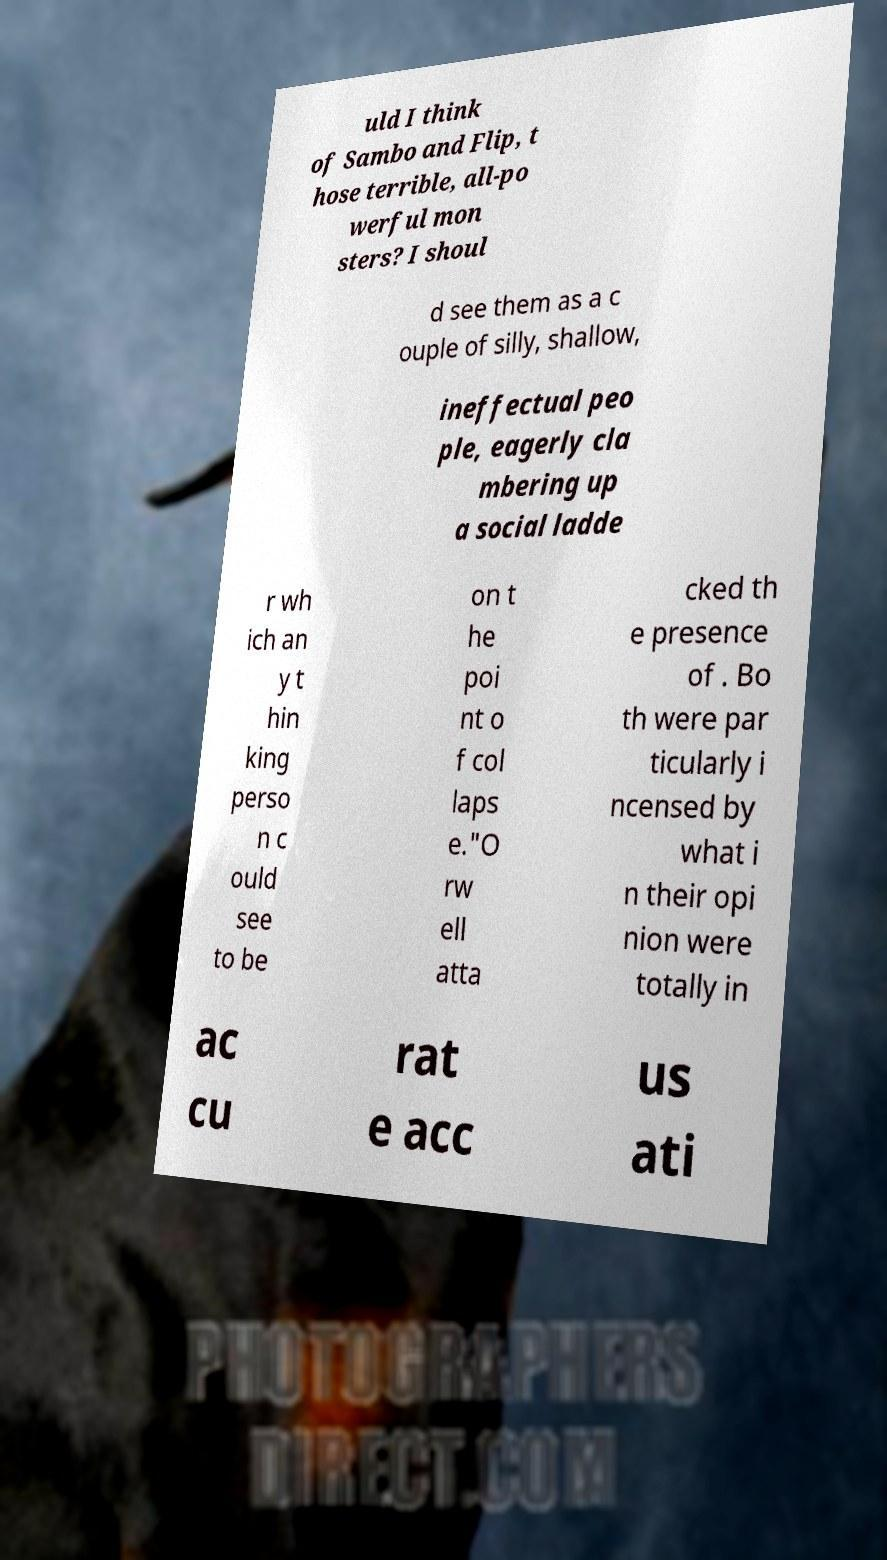Please identify and transcribe the text found in this image. uld I think of Sambo and Flip, t hose terrible, all-po werful mon sters? I shoul d see them as a c ouple of silly, shallow, ineffectual peo ple, eagerly cla mbering up a social ladde r wh ich an y t hin king perso n c ould see to be on t he poi nt o f col laps e."O rw ell atta cked th e presence of . Bo th were par ticularly i ncensed by what i n their opi nion were totally in ac cu rat e acc us ati 